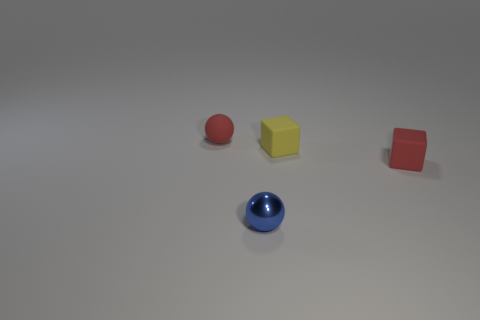How many objects are there, and can you describe their colors and shapes? There are four objects in the image. Starting from the left, there's a red spherical object, a yellow cube, a red cube, and a blue spherical object. The color palette seems primary and the shapes are distinctly recognizable as a sphere and cube. 